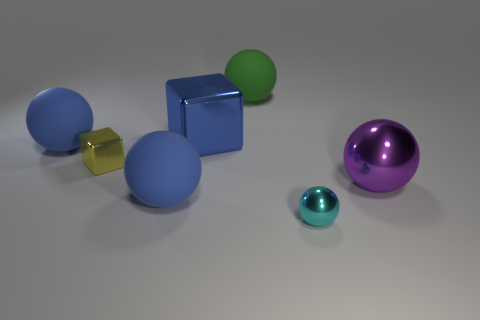Subtract all purple balls. How many balls are left? 4 Subtract all large purple balls. How many balls are left? 4 Subtract all yellow spheres. Subtract all red cylinders. How many spheres are left? 5 Add 2 tiny cyan metallic objects. How many objects exist? 9 Subtract all spheres. How many objects are left? 2 Add 4 big green objects. How many big green objects exist? 5 Subtract 0 purple cubes. How many objects are left? 7 Subtract all tiny metallic cylinders. Subtract all small cyan metal objects. How many objects are left? 6 Add 6 tiny cyan balls. How many tiny cyan balls are left? 7 